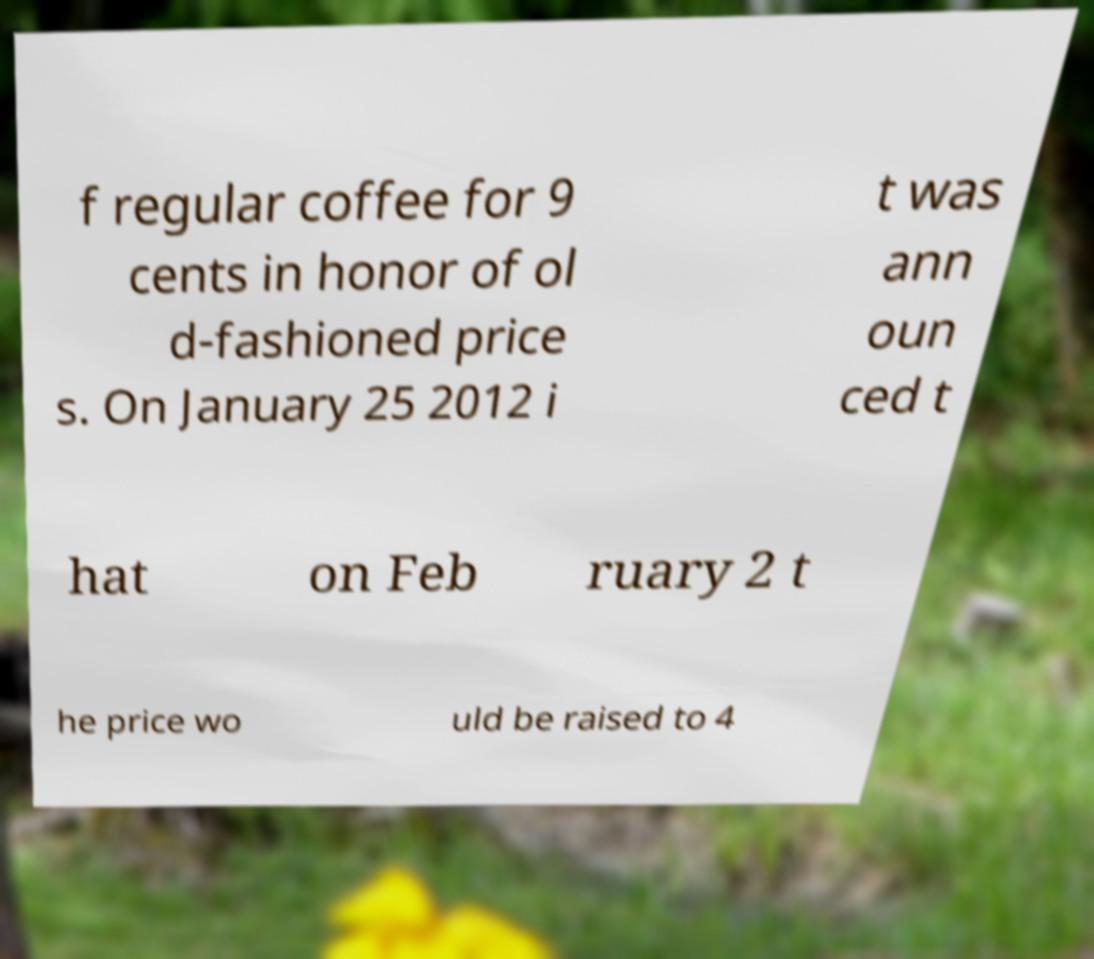What messages or text are displayed in this image? I need them in a readable, typed format. f regular coffee for 9 cents in honor of ol d-fashioned price s. On January 25 2012 i t was ann oun ced t hat on Feb ruary 2 t he price wo uld be raised to 4 